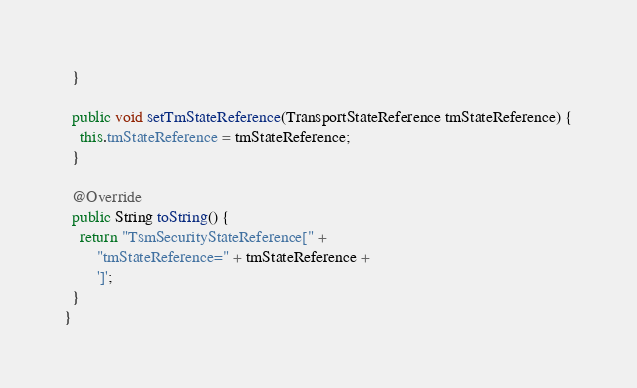Convert code to text. <code><loc_0><loc_0><loc_500><loc_500><_Java_>  }

  public void setTmStateReference(TransportStateReference tmStateReference) {
    this.tmStateReference = tmStateReference;
  }

  @Override
  public String toString() {
    return "TsmSecurityStateReference[" +
        "tmStateReference=" + tmStateReference +
        ']';
  }
}
</code> 